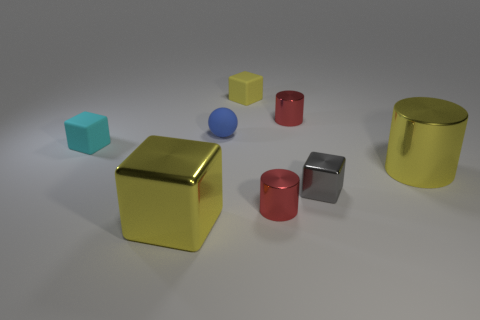Subtract all balls. How many objects are left? 7 Add 1 large yellow cylinders. How many objects exist? 9 Subtract all metal cylinders. Subtract all yellow cylinders. How many objects are left? 4 Add 2 red metal cylinders. How many red metal cylinders are left? 4 Add 7 tiny red rubber cubes. How many tiny red rubber cubes exist? 7 Subtract 1 cyan blocks. How many objects are left? 7 